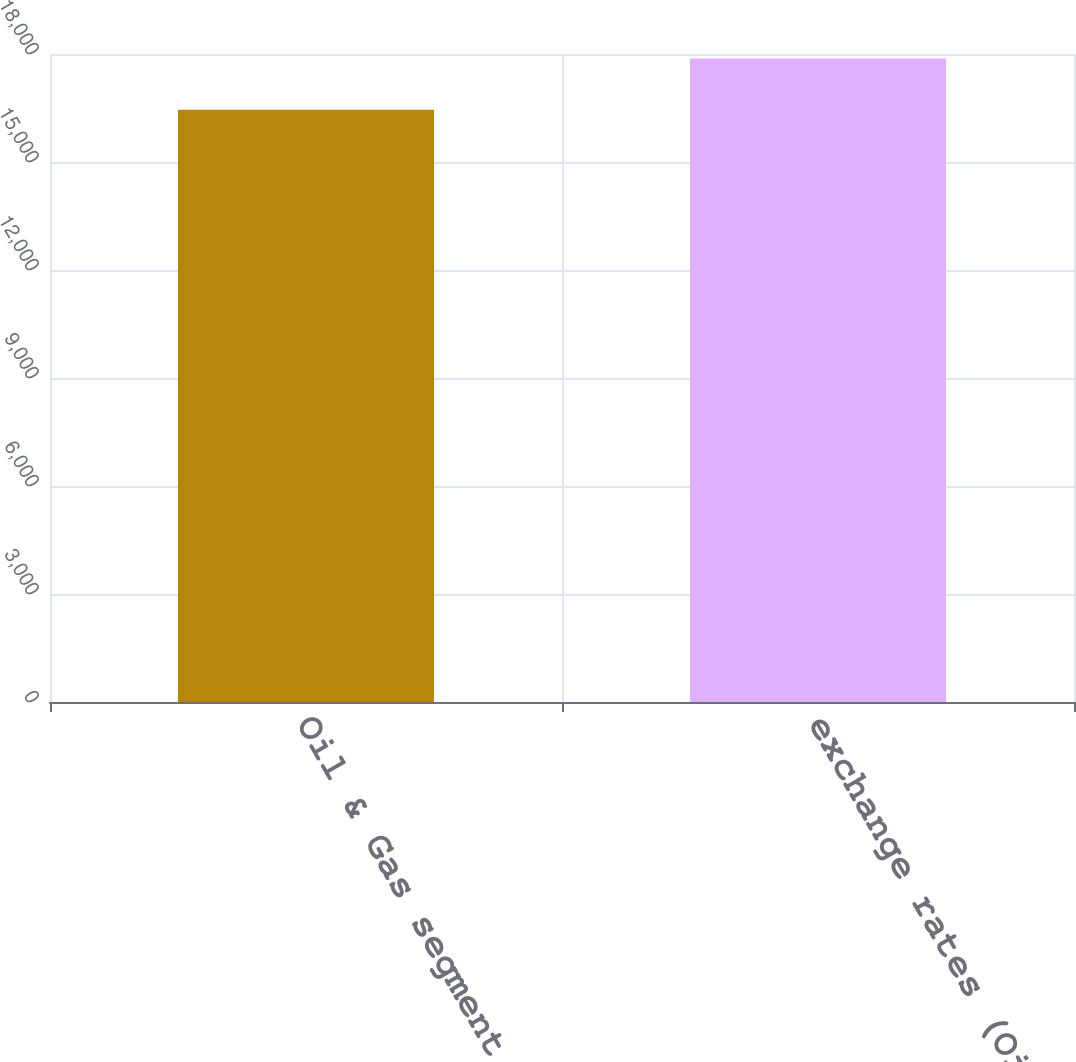Convert chart. <chart><loc_0><loc_0><loc_500><loc_500><bar_chart><fcel>Oil & Gas segment revenue<fcel>exchange rates (Oil & Gas<nl><fcel>16450<fcel>17878<nl></chart> 